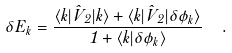<formula> <loc_0><loc_0><loc_500><loc_500>\delta E _ { k } = \frac { \langle k | \hat { V } _ { 2 } | k \rangle + \langle k | \hat { V } _ { 2 } | \delta \phi _ { k } \rangle } { 1 + \langle k | \delta \phi _ { k } \rangle } \ \ .</formula> 